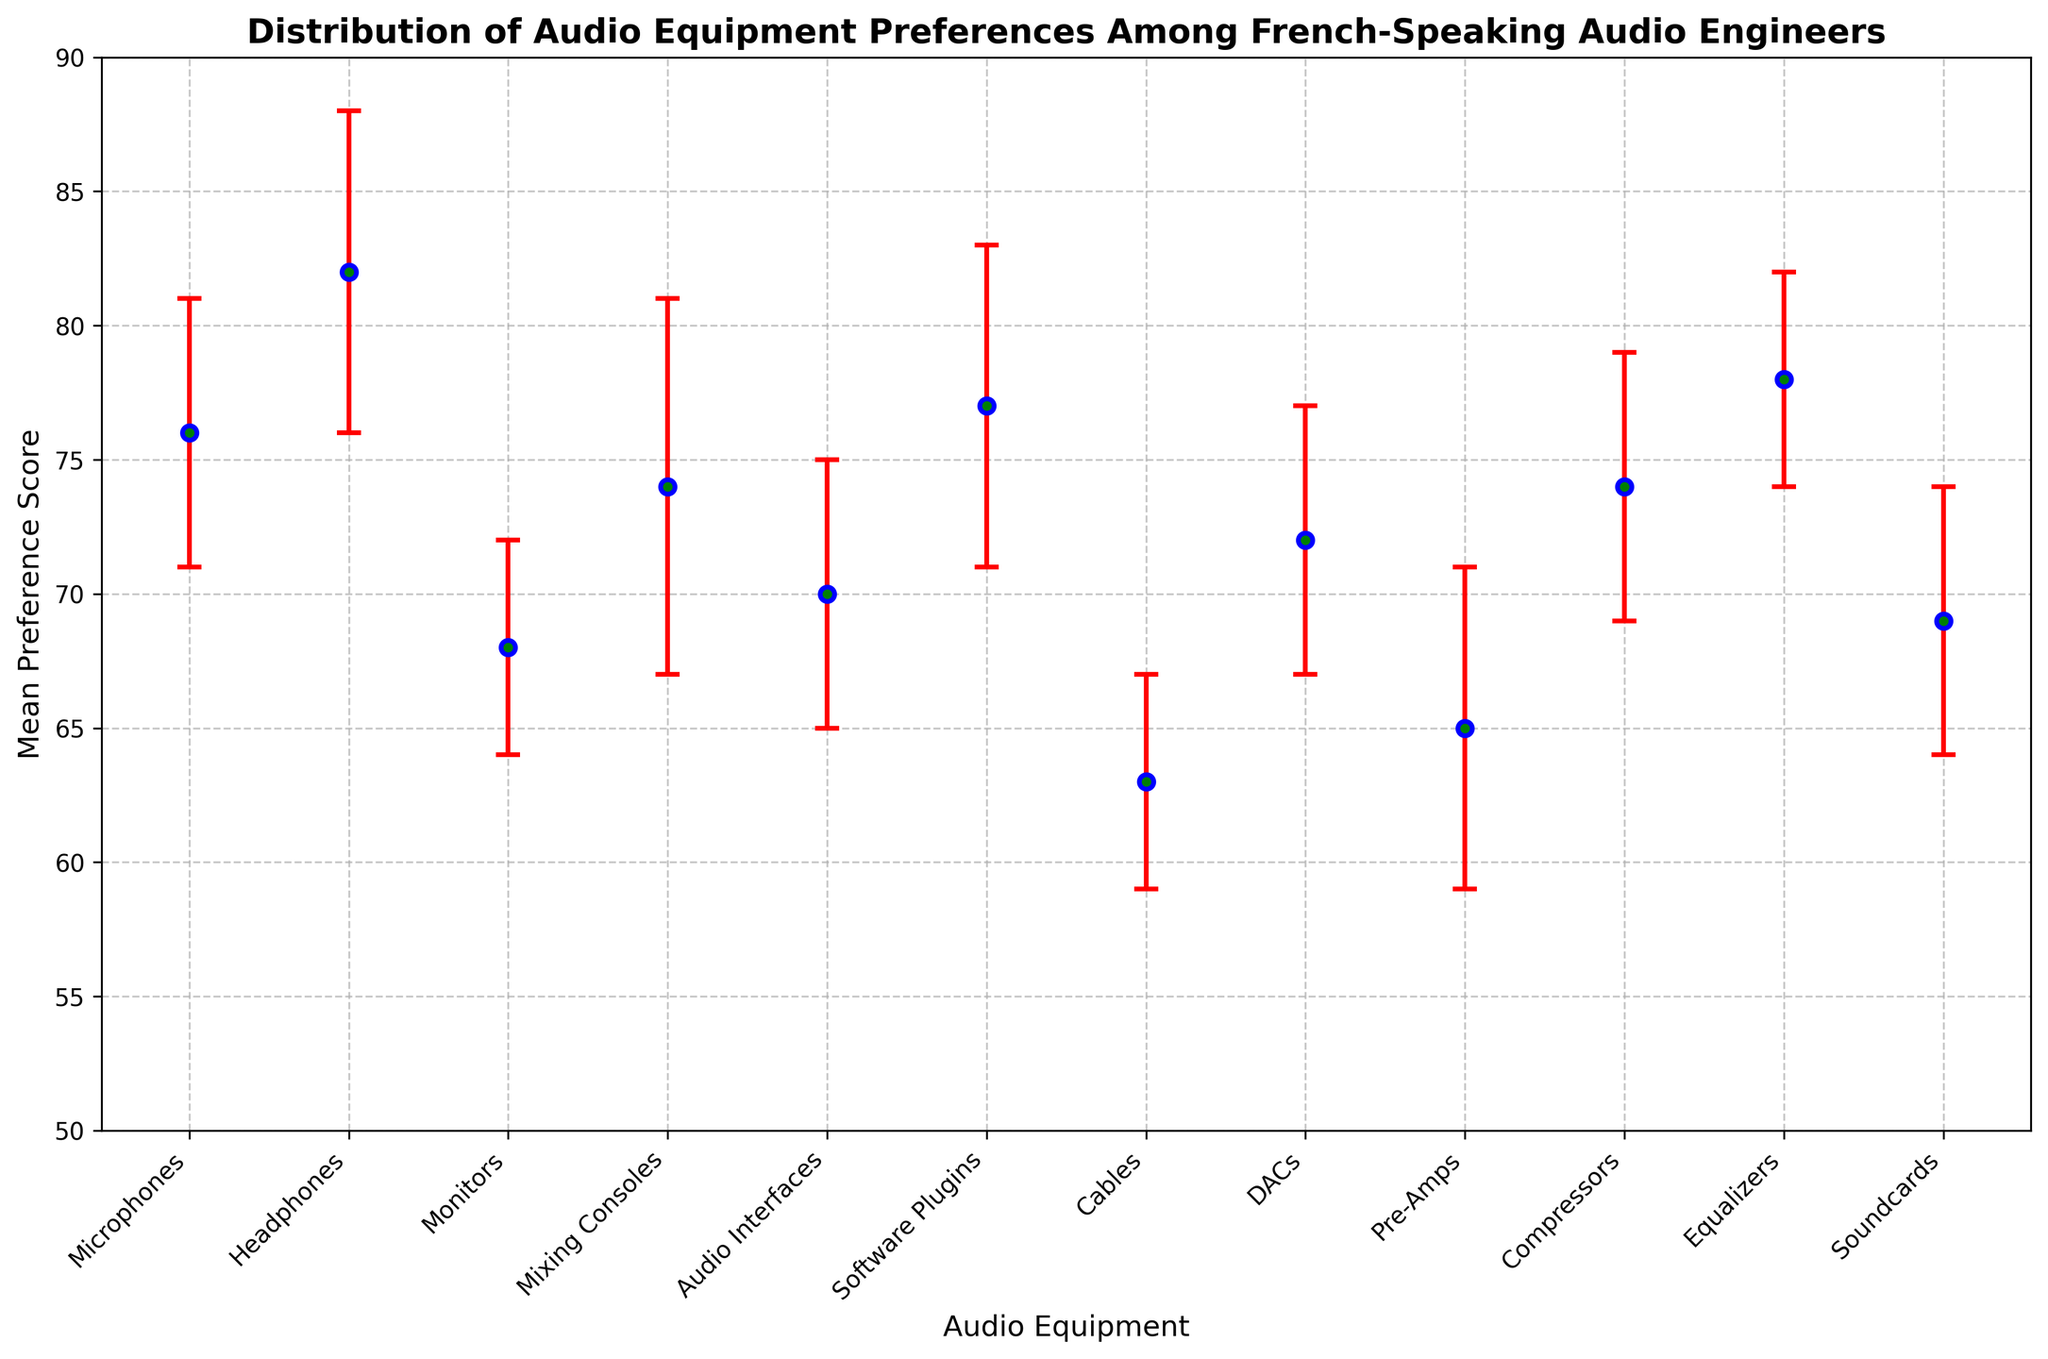Which equipment has the highest mean preference score? The equipment with the highest mean preference score is identified by locating the point with the highest y-value (Mean Preference Score) on the y-axis.
Answer: Headphones What is the mean preference score difference between Headphones and Cables? Look at the y-values for Headphones and Cables and subtract the mean preference score of Cables from that of Headphones: 82 - 63.
Answer: 19 Which equipment has the largest variation in preference, and how is this visually represented? The equipment with the largest variation in preference is the one with the largest error bar. Mixing Consoles have the largest error bar, indicating the highest standard deviation (7).
Answer: Mixing Consoles What is the combined mean preference score for Audio Interfaces and DACs? Sum the mean preference scores for Audio Interfaces and DACs: 70 + 72.
Answer: 142 Which equipment has a standard deviation equal to that of Microphones? Identify the standard deviation of Microphones (5) and find another equipment with the same standard deviation. Audio Interfaces have a standard deviation of 5.
Answer: Audio Interfaces What is the mean preference score for equipment with the lowest mean preference score? Find the equipment with the lowest mean preference score by identifying the point with the lowest y-value. Cables have the lowest mean preference score (63).
Answer: 63 Is the mean preference score for Software Plugins greater than or equal to that of Equalizers? Compare the mean preference scores for Software Plugins (77) and Equalizers (78). Since 77 is less than 78, the statement is false.
Answer: No Which equipment has a higher preference score, Soundcards or Pre-Amps, and what are the scores? Compare the mean preference scores for Soundcards (69) and Pre-Amps (65). Soundcards have a higher mean preference score.
Answer: Soundcards (69) What is the average standard deviation of all the equipment? Sum the standard deviations (5+6+4+7+5+6+4+5+6+5+4+5) and divide by the number of equipment (12): (62 / 12).
Answer: 5.17 What is the range of the mean preference scores for all equipment? Identify the maximum (82 for Headphones) and minimum (63 for Cables) mean preference scores and calculate the range: 82 - 63.
Answer: 19 